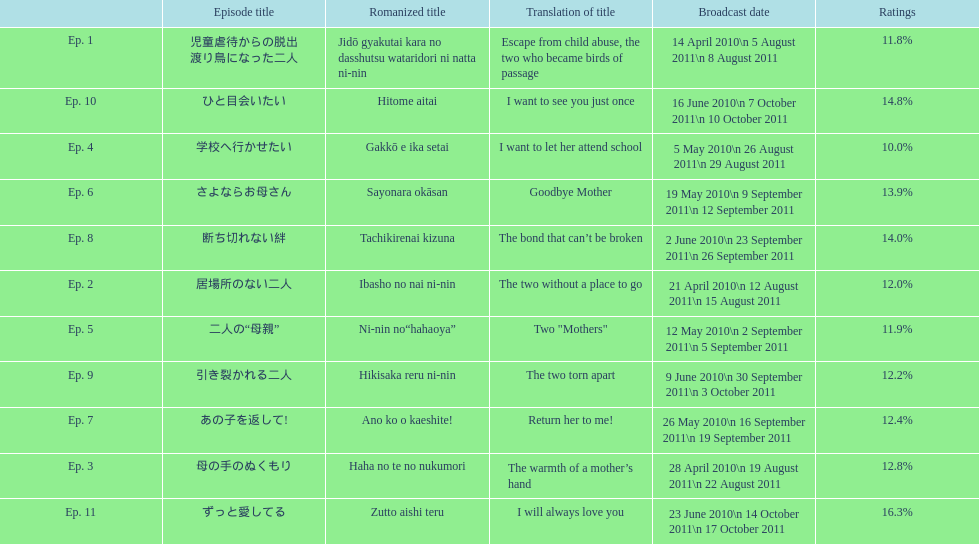How many episode total are there? 11. 